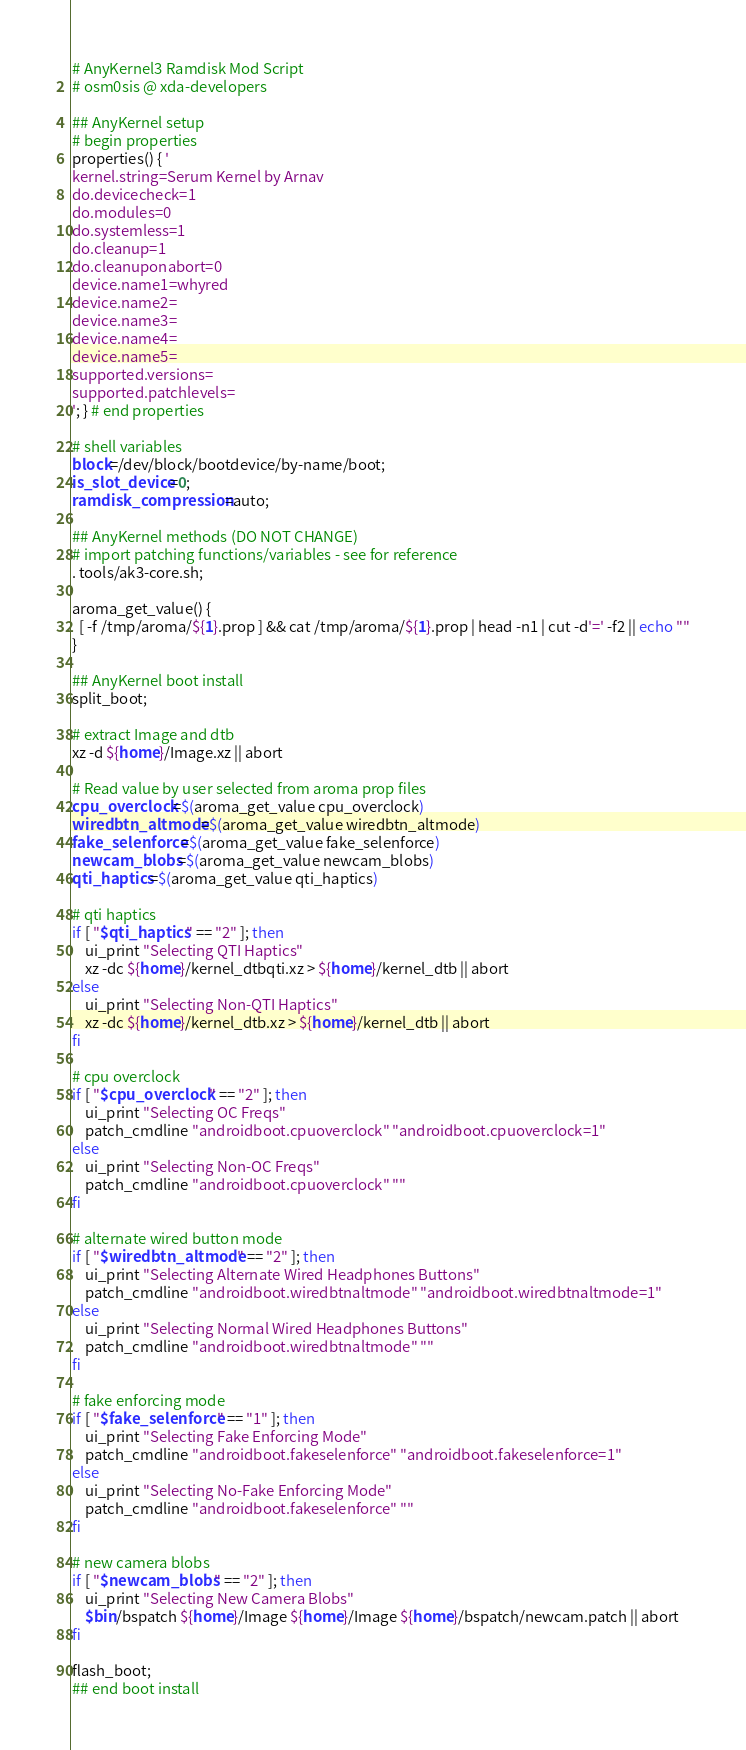<code> <loc_0><loc_0><loc_500><loc_500><_Bash_># AnyKernel3 Ramdisk Mod Script
# osm0sis @ xda-developers

## AnyKernel setup
# begin properties
properties() { '
kernel.string=Serum Kernel by Arnav
do.devicecheck=1
do.modules=0
do.systemless=1
do.cleanup=1
do.cleanuponabort=0
device.name1=whyred
device.name2=
device.name3=
device.name4=
device.name5=
supported.versions=
supported.patchlevels=
'; } # end properties

# shell variables
block=/dev/block/bootdevice/by-name/boot;
is_slot_device=0;
ramdisk_compression=auto;

## AnyKernel methods (DO NOT CHANGE)
# import patching functions/variables - see for reference
. tools/ak3-core.sh;

aroma_get_value() {
  [ -f /tmp/aroma/${1}.prop ] && cat /tmp/aroma/${1}.prop | head -n1 | cut -d'=' -f2 || echo ""
}

## AnyKernel boot install
split_boot;

# extract Image and dtb
xz -d ${home}/Image.xz || abort

# Read value by user selected from aroma prop files
cpu_overclock=$(aroma_get_value cpu_overclock)
wiredbtn_altmode=$(aroma_get_value wiredbtn_altmode)
fake_selenforce=$(aroma_get_value fake_selenforce)
newcam_blobs=$(aroma_get_value newcam_blobs)
qti_haptics=$(aroma_get_value qti_haptics)

# qti haptics
if [ "$qti_haptics" == "2" ]; then
    ui_print "Selecting QTI Haptics"
    xz -dc ${home}/kernel_dtbqti.xz > ${home}/kernel_dtb || abort
else
    ui_print "Selecting Non-QTI Haptics"
    xz -dc ${home}/kernel_dtb.xz > ${home}/kernel_dtb || abort
fi

# cpu overclock
if [ "$cpu_overclock" == "2" ]; then
    ui_print "Selecting OC Freqs"
    patch_cmdline "androidboot.cpuoverclock" "androidboot.cpuoverclock=1"
else
    ui_print "Selecting Non-OC Freqs"
    patch_cmdline "androidboot.cpuoverclock" ""
fi

# alternate wired button mode
if [ "$wiredbtn_altmode" == "2" ]; then
    ui_print "Selecting Alternate Wired Headphones Buttons"
    patch_cmdline "androidboot.wiredbtnaltmode" "androidboot.wiredbtnaltmode=1"
else
    ui_print "Selecting Normal Wired Headphones Buttons"
    patch_cmdline "androidboot.wiredbtnaltmode" ""
fi

# fake enforcing mode
if [ "$fake_selenforce" == "1" ]; then
    ui_print "Selecting Fake Enforcing Mode"
    patch_cmdline "androidboot.fakeselenforce" "androidboot.fakeselenforce=1"
else
    ui_print "Selecting No-Fake Enforcing Mode"
    patch_cmdline "androidboot.fakeselenforce" ""
fi

# new camera blobs
if [ "$newcam_blobs" == "2" ]; then
    ui_print "Selecting New Camera Blobs"
    $bin/bspatch ${home}/Image ${home}/Image ${home}/bspatch/newcam.patch || abort
fi

flash_boot;
## end boot install
</code> 